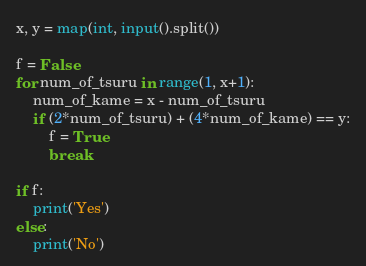Convert code to text. <code><loc_0><loc_0><loc_500><loc_500><_Python_>x, y = map(int, input().split())

f = False
for num_of_tsuru in range(1, x+1):
    num_of_kame = x - num_of_tsuru
    if (2*num_of_tsuru) + (4*num_of_kame) == y:
        f = True
        break

if f:
    print('Yes')
else:
    print('No')</code> 